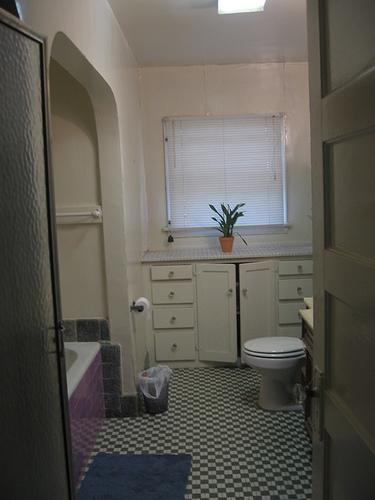How many draws are in the cabinet?
Give a very brief answer. 8. How many handles does the drawer have?
Give a very brief answer. 1. How many TVs are visible?
Give a very brief answer. 0. How many light sources are in the room?
Give a very brief answer. 1. How many rolls of toilet paper can be seen?
Give a very brief answer. 1. 